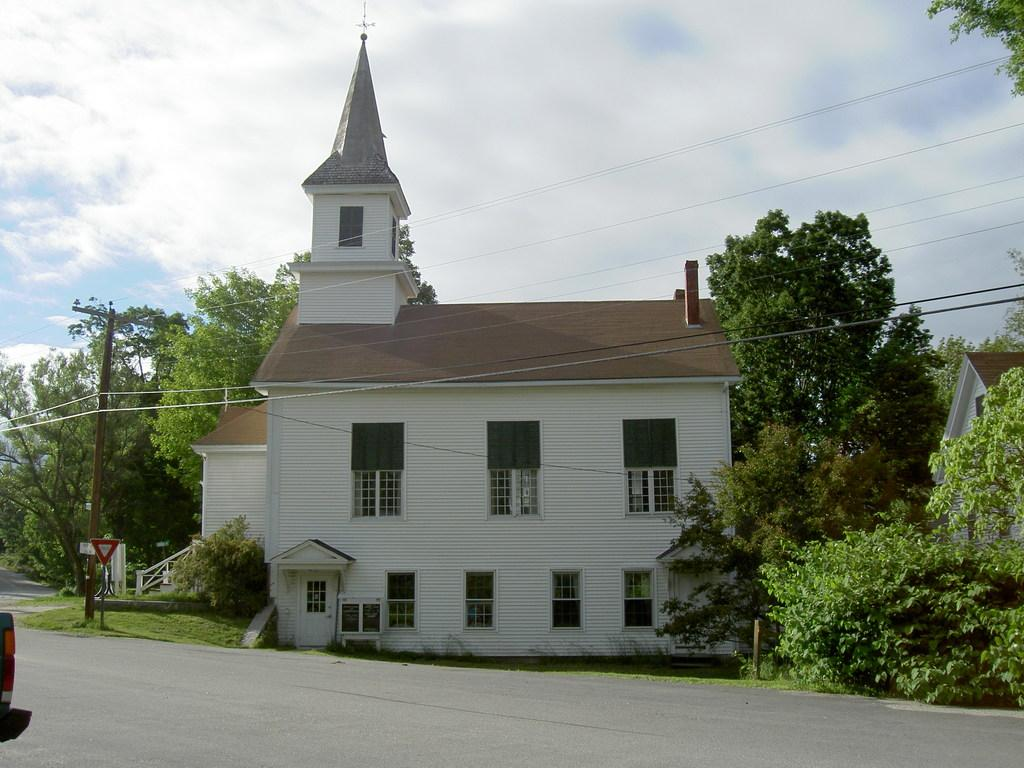What type of vegetation can be seen in the image? There are trees and plants visible in the image. What type of structures are present in the image? There are houses in the image. What else can be seen attached to the pole besides the wires? The provided facts do not mention any other objects attached to the pole. What type of ground cover is visible in the image? There is grass visible in the image. What else can be seen in the image besides the mentioned objects? There are other unspecified objects in the image. What is visible in the background of the image? The sky is visible in the background of the image. Where is the faucet located in the image? There is no faucet present in the image. What type of music is being played on the guitar in the image? There is no guitar present in the image. 